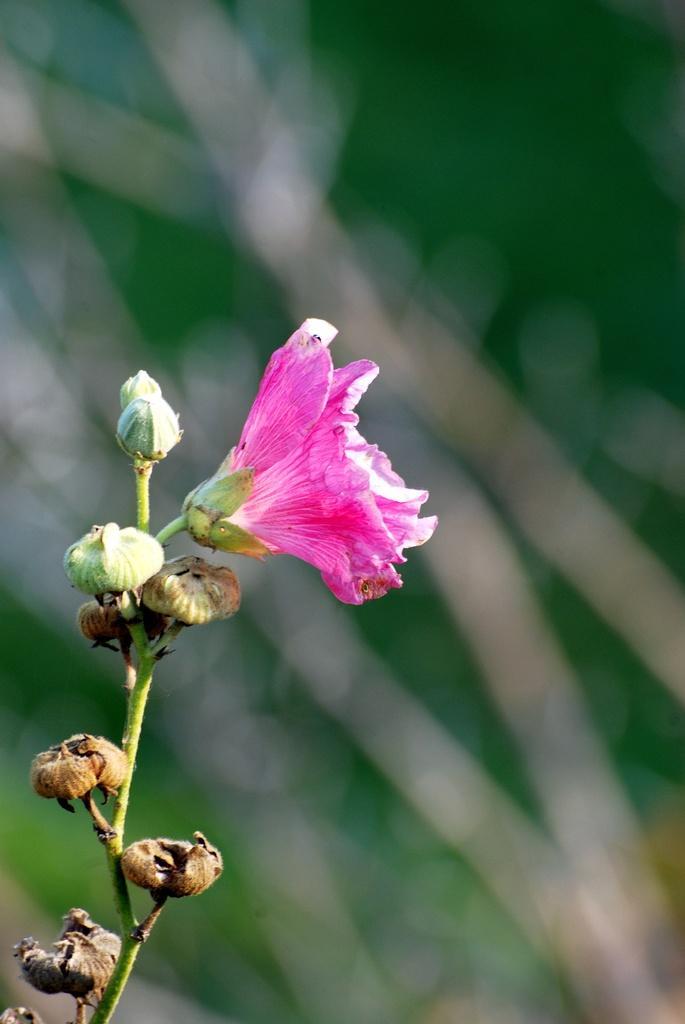How would you summarize this image in a sentence or two? In this picture there is a pink color flower and there are buds on the plant. At the back the image is blurry. 